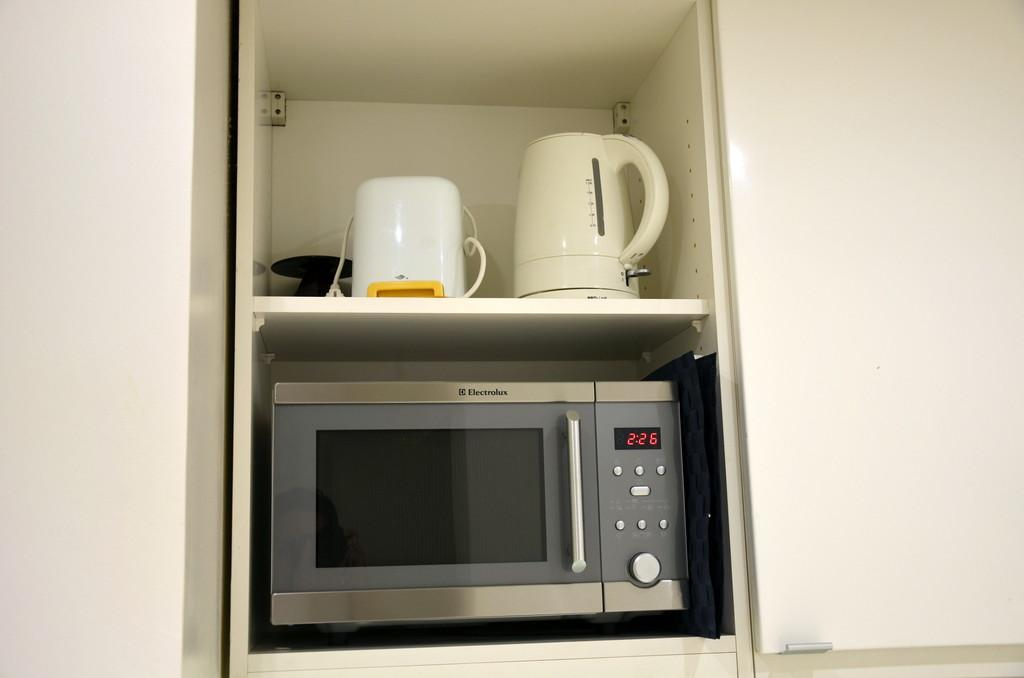Provide a one-sentence caption for the provided image. a microwave oven that says '2:26' on it. 